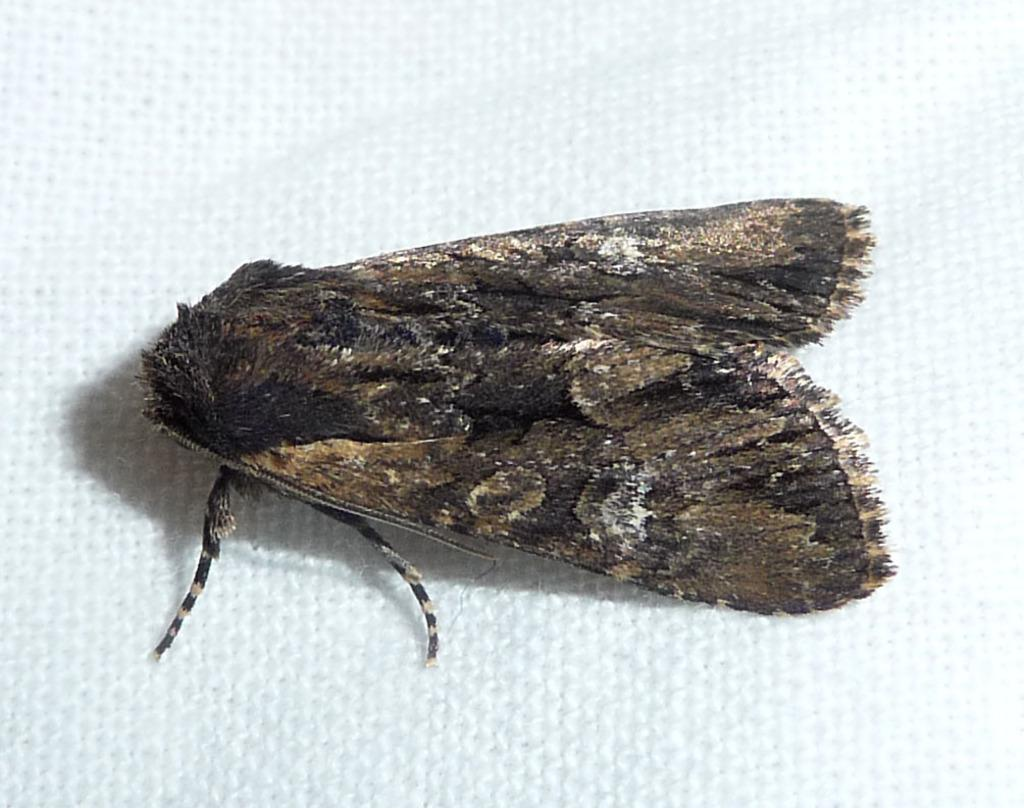What is the main subject of the image? There is a moth in the image. Where is the moth located? The moth is on a white cloth. What type of smell can be detected from the moth in the image? There is no mention of a smell in the image, and therefore it cannot be determined from the image. 